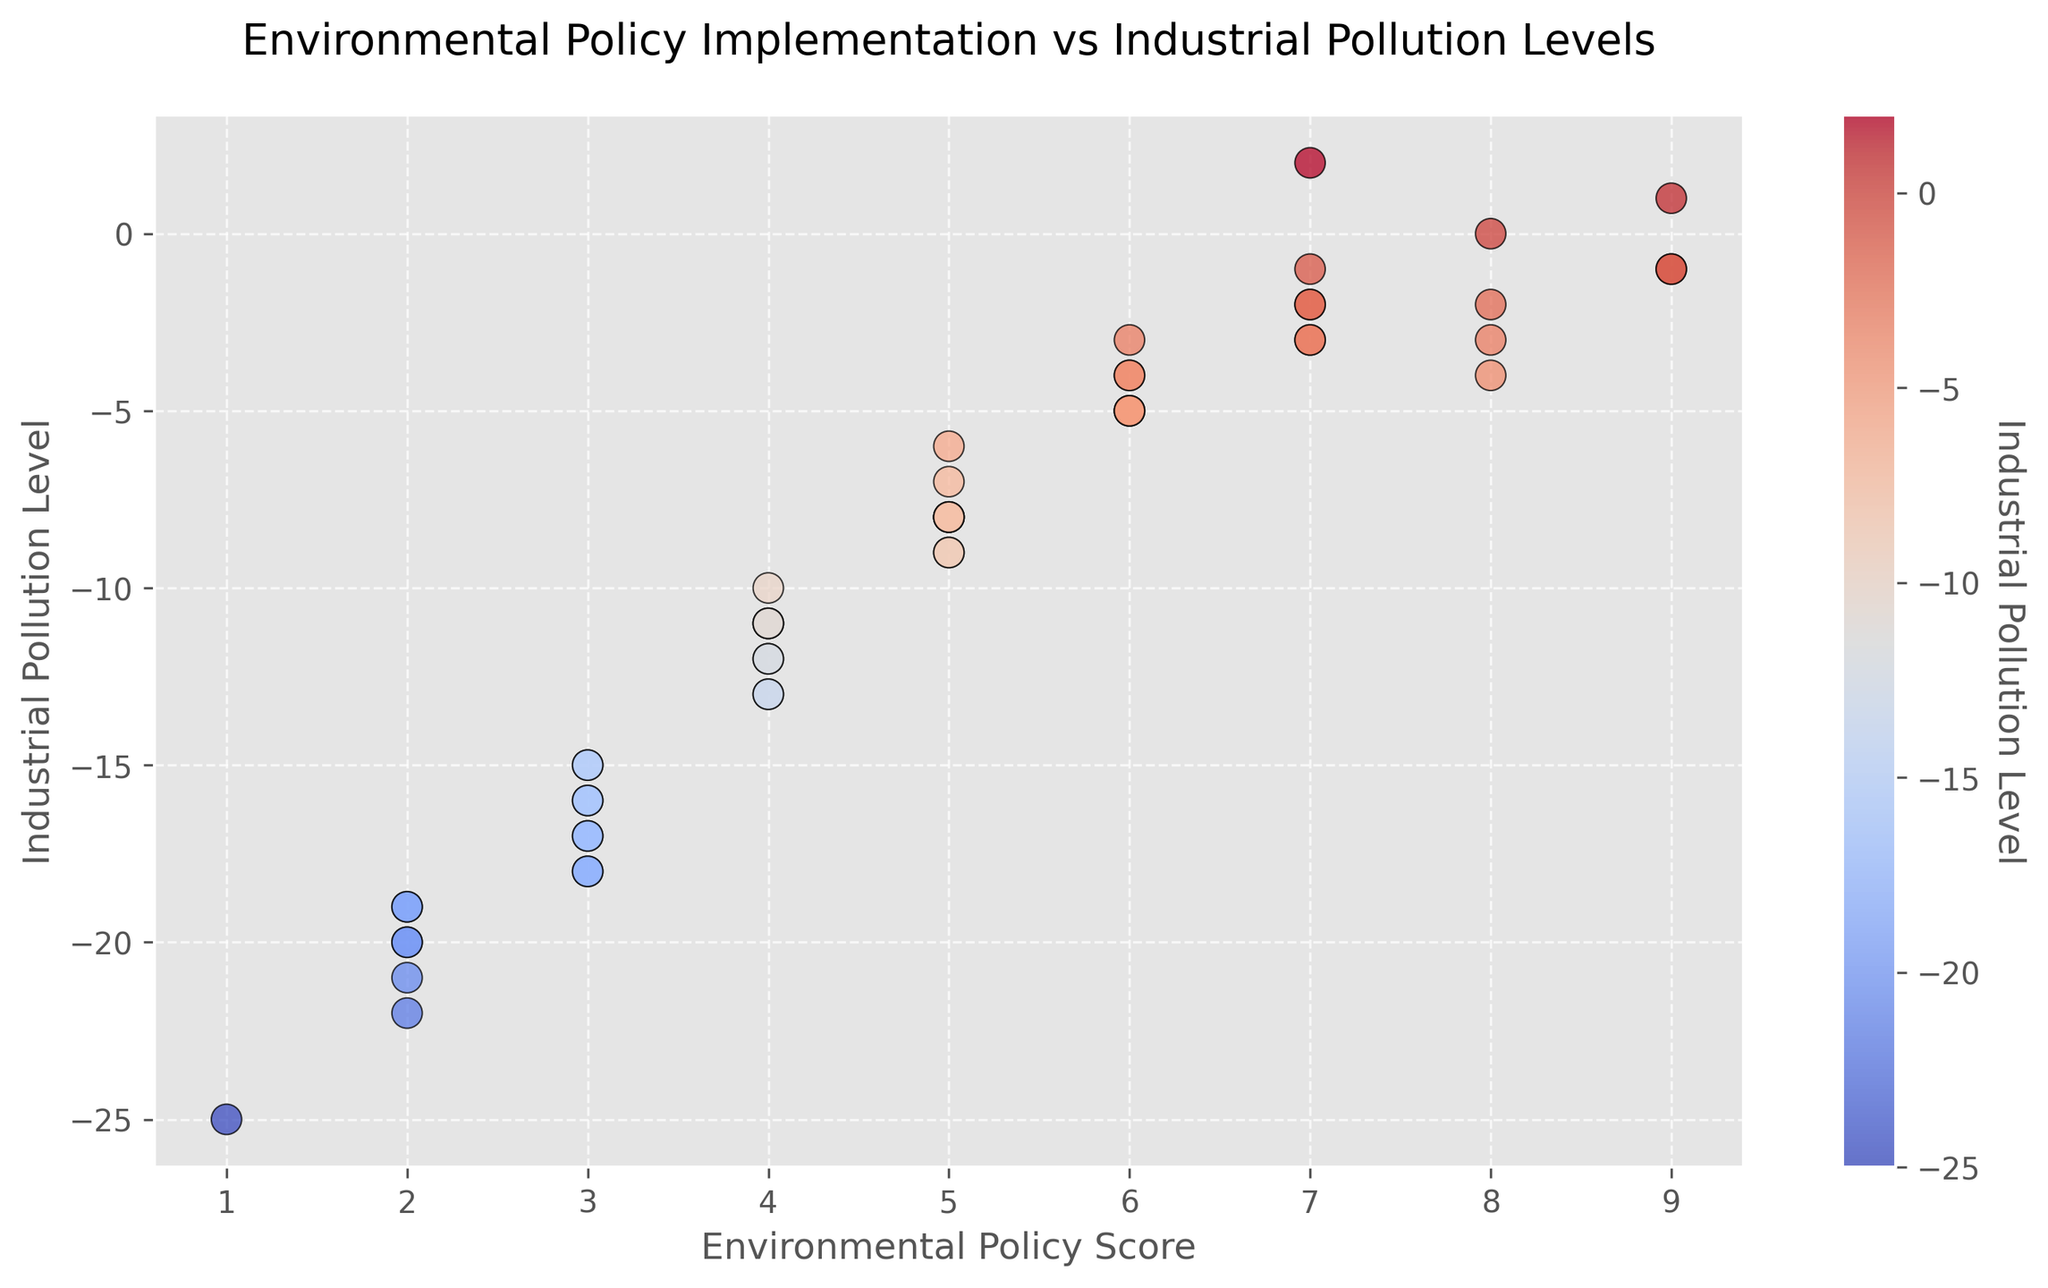What is the highest Environmental Policy Score observed in the plot? Looking at the scatter plot, identify the highest point on the x-axis, as that represents the highest Environmental Policy Score. The highest score is observed where the score reaches 9.
Answer: 9 Which state has the most industrial pollution levels and what is the corresponding Environmental Policy Score? Find the point with the highest pollution level on the y-axis. The state with the most pollution has a level of -25, corresponding to an Environmental Policy Score of 1, which is Louisiana.
Answer: Louisiana, 1 Is there a clear correlation between Environmental Policy Score and Industrial Pollution Level? Visually inspect the scatter plot to see if there's a trend. The scatter points lack a clear linear pattern, indicating there might not be a strong or straightforward correlation between the two variables.
Answer: No clear correlation What is the median value of the Environmental Policy Scores in the scatter plot? List out all Environmental Policy Scores and find the middle value. The scores range from 1 to 9. To calculate the median, arrange scores in order and find the middle value. Considering there are 50 data points, the median is the average of the 25th and 26th scores. As the scores mostly range from 1 to 9 multiple times, the median is likely to be around 5.5.
Answer: 5.5 How does the pollution level for states with the highest environmental policy score compare to those with the lowest score? Focus on states with highest score (9) and lowest score (1). Highest score (California, Massachusetts, Vermont) have pollution levels around -1 to 1. The lowest score (Louisiana) has a pollution level of -25. Higher scores often correspond to lower pollution.
Answer: Higher scores, Lower pollution Which state has the combination of a moderate policy score (4-6) and lowest pollution level? Look at the scatter points with Environmental Policy Scores between 4 and 6. Identify the point closest to the highest y-axis. Score 6 and pollution level -2 in Maryland meets this criteria.
Answer: Maryland Are there any outliers in terms of states having relatively high pollution but moderate environmental policy scores? Examine scatter points for outliers (e.g., points that diverge from the general trend). Several states with Environmental Policy Scores around 4 have higher pollution (e.g., Michigan, -13).
Answer: Michigan Identify the color bar range and explain what it represents about pollution levels. Look at the color bar next to the scatter plot. Cool colors (blue) represent lower pollution and warm colors (red) represent higher pollution. The range typically spans -25 to 1, illustrating pollution levels from lowest to highest.
Answer: -25 to 1 What is the average pollution level for states with environmental policy scores above 5? Identify states with scores >5, sum their pollution levels and divide by number of such states. Scores above 5 correspond to 6 states: (6*(-3)+4*(-4)+1*2 +3*1)/6 = -1.5
Answer: -1.5 